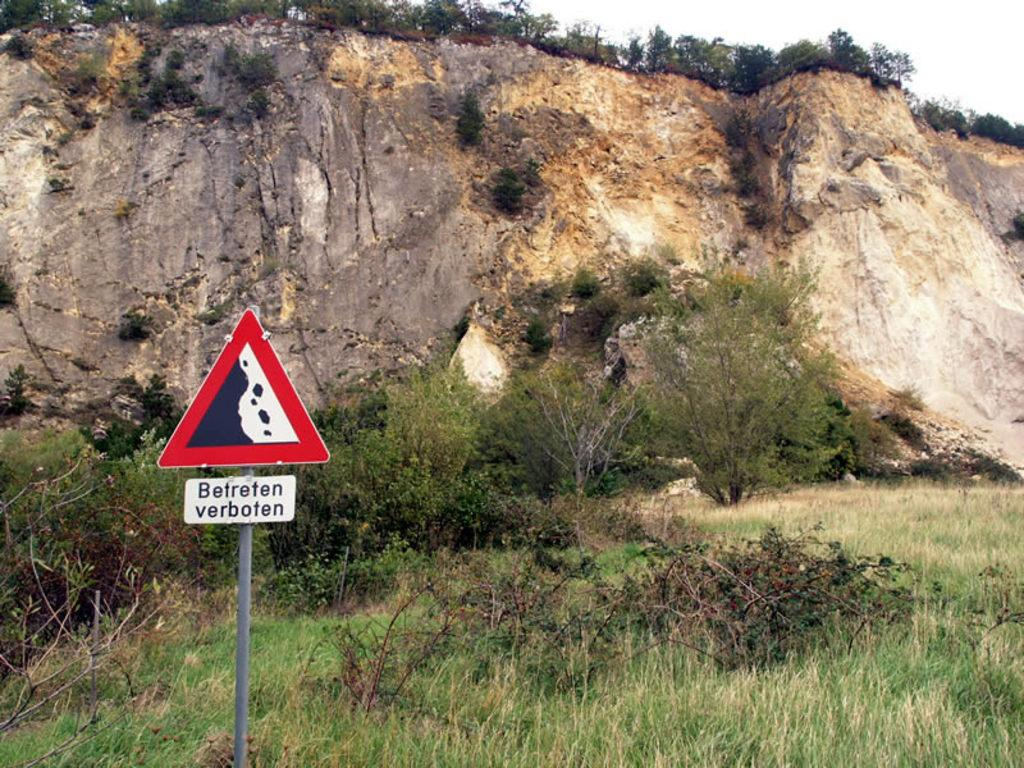<image>
Offer a succinct explanation of the picture presented. A sign that says Betreten verboten in front of a cliff. 